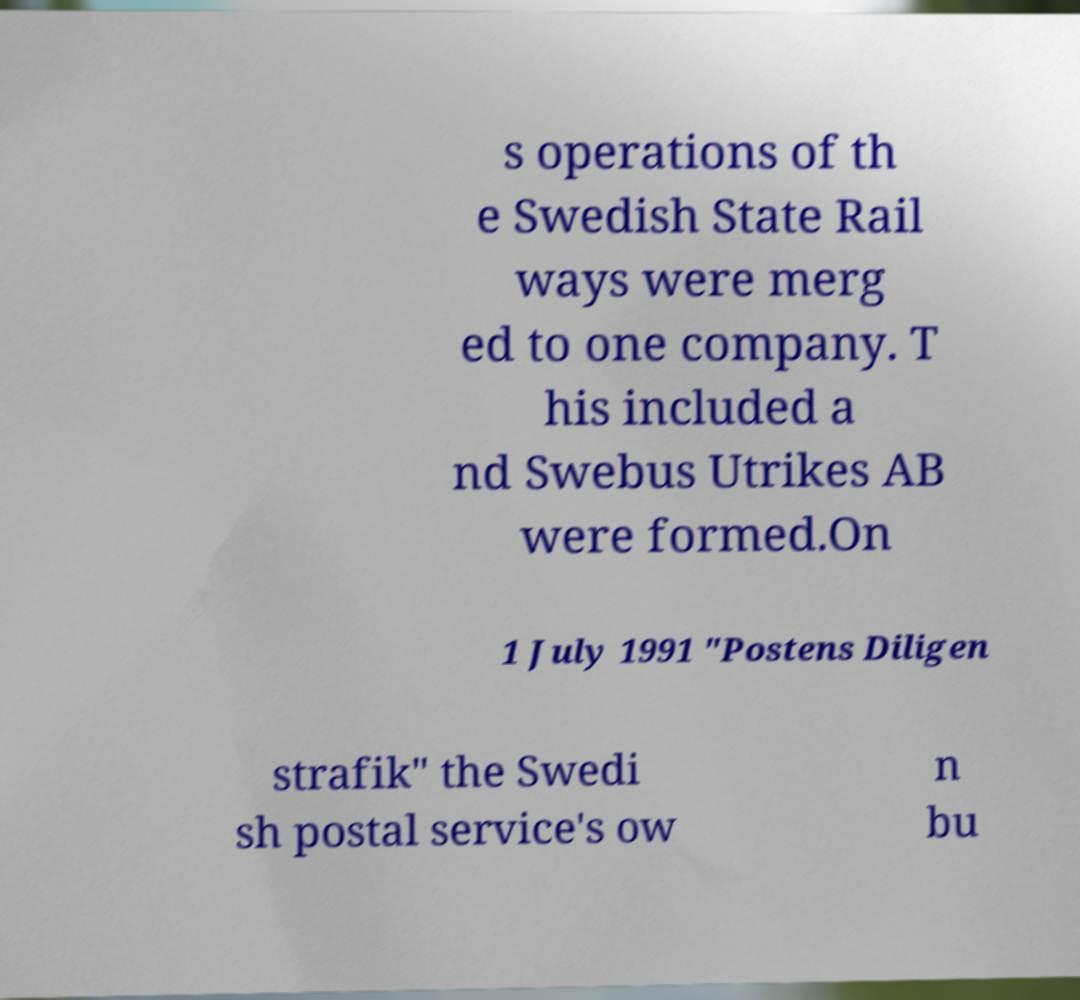Can you read and provide the text displayed in the image?This photo seems to have some interesting text. Can you extract and type it out for me? s operations of th e Swedish State Rail ways were merg ed to one company. T his included a nd Swebus Utrikes AB were formed.On 1 July 1991 "Postens Diligen strafik" the Swedi sh postal service's ow n bu 